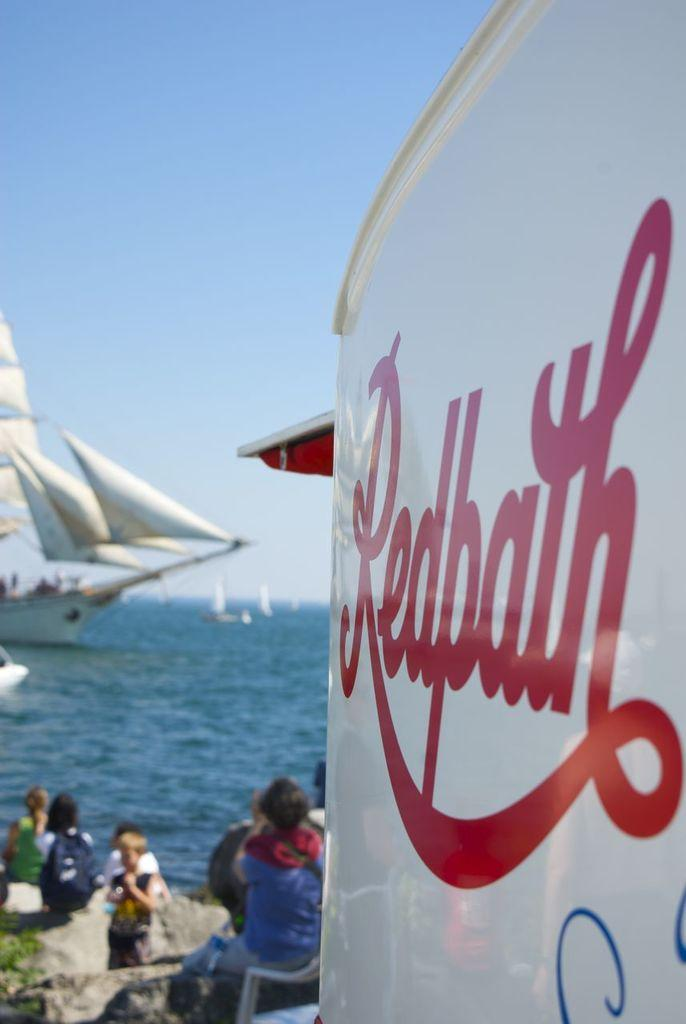<image>
Create a compact narrative representing the image presented. A wall with Redbath written in red on the white in front of a boat. 